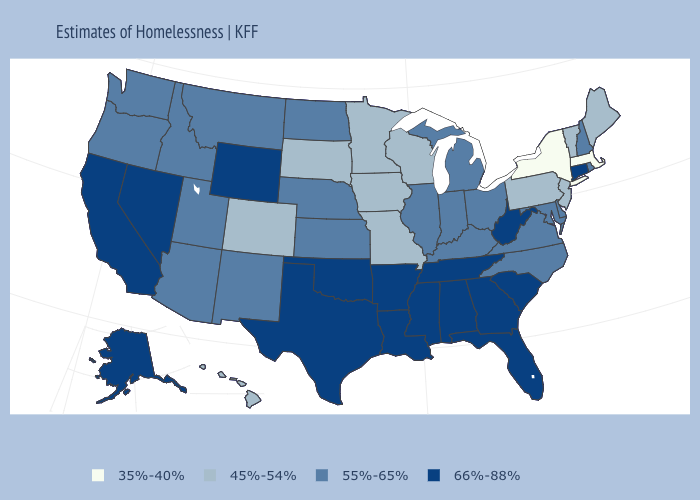Among the states that border Connecticut , which have the lowest value?
Keep it brief. Massachusetts, New York. Does Nebraska have a higher value than Missouri?
Keep it brief. Yes. Name the states that have a value in the range 55%-65%?
Concise answer only. Arizona, Delaware, Idaho, Illinois, Indiana, Kansas, Kentucky, Maryland, Michigan, Montana, Nebraska, New Hampshire, New Mexico, North Carolina, North Dakota, Ohio, Oregon, Rhode Island, Utah, Virginia, Washington. What is the value of Maine?
Give a very brief answer. 45%-54%. Which states have the lowest value in the USA?
Answer briefly. Massachusetts, New York. What is the value of Virginia?
Answer briefly. 55%-65%. Which states have the lowest value in the South?
Concise answer only. Delaware, Kentucky, Maryland, North Carolina, Virginia. Name the states that have a value in the range 45%-54%?
Answer briefly. Colorado, Hawaii, Iowa, Maine, Minnesota, Missouri, New Jersey, Pennsylvania, South Dakota, Vermont, Wisconsin. Does Maryland have a lower value than Oregon?
Write a very short answer. No. What is the value of Tennessee?
Answer briefly. 66%-88%. Name the states that have a value in the range 45%-54%?
Short answer required. Colorado, Hawaii, Iowa, Maine, Minnesota, Missouri, New Jersey, Pennsylvania, South Dakota, Vermont, Wisconsin. Which states have the highest value in the USA?
Give a very brief answer. Alabama, Alaska, Arkansas, California, Connecticut, Florida, Georgia, Louisiana, Mississippi, Nevada, Oklahoma, South Carolina, Tennessee, Texas, West Virginia, Wyoming. Name the states that have a value in the range 35%-40%?
Short answer required. Massachusetts, New York. Name the states that have a value in the range 66%-88%?
Give a very brief answer. Alabama, Alaska, Arkansas, California, Connecticut, Florida, Georgia, Louisiana, Mississippi, Nevada, Oklahoma, South Carolina, Tennessee, Texas, West Virginia, Wyoming. Does Idaho have a higher value than Oklahoma?
Keep it brief. No. 